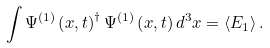<formula> <loc_0><loc_0><loc_500><loc_500>\int { \Psi ^ { \left ( 1 \right ) } \left ( { { x } , t } \right ) ^ { \dag } \Psi ^ { \left ( 1 \right ) } \left ( { { x } , t } \right ) d ^ { 3 } x } = \left \langle { E _ { 1 } } \right \rangle .</formula> 